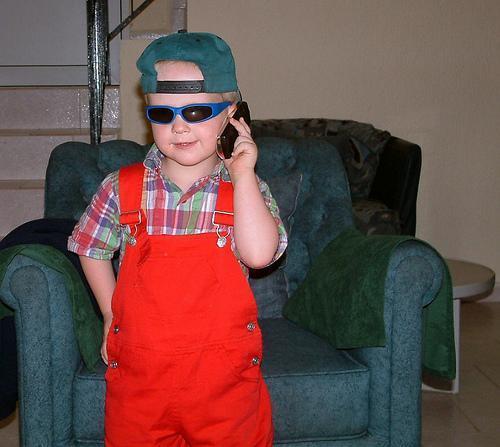Is "The couch is behind the person." an appropriate description for the image?
Answer yes or no. Yes. 